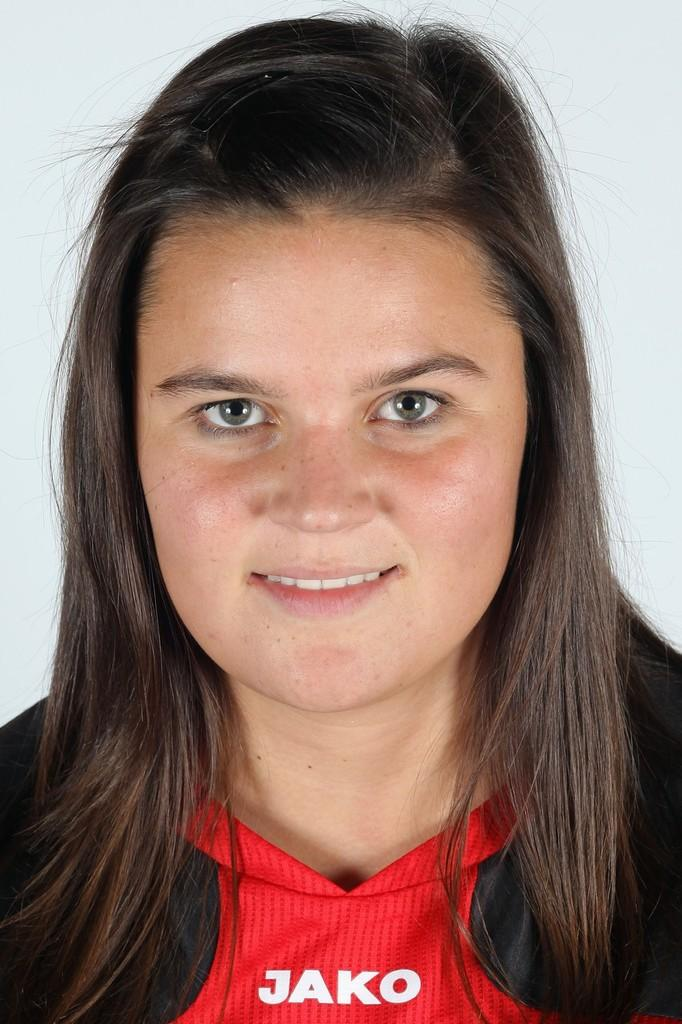Who is present in the image? There is a girl in the image. What expression does the girl have? The girl is smiling. What type of straw is the girl using for her hobbies during the journey in the image? There is no straw, hobbies, or journey present in the image; it only features a girl who is smiling. 